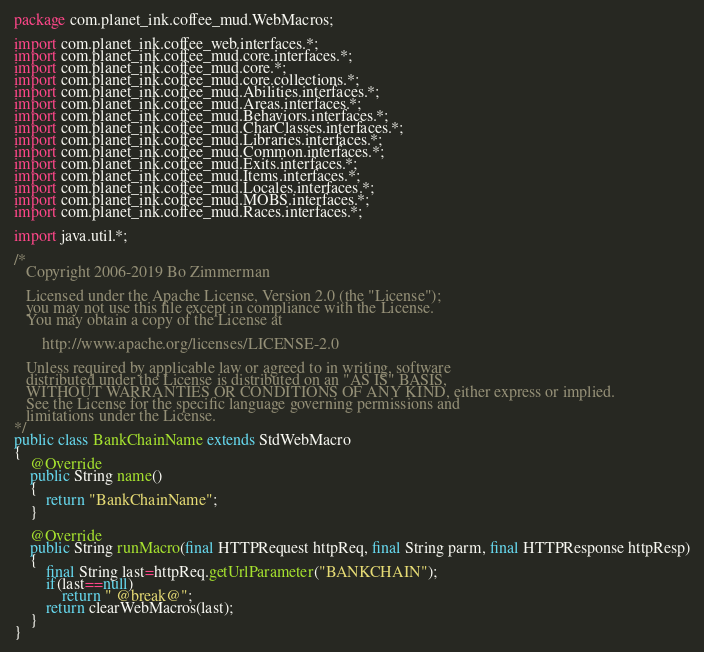Convert code to text. <code><loc_0><loc_0><loc_500><loc_500><_Java_>package com.planet_ink.coffee_mud.WebMacros;

import com.planet_ink.coffee_web.interfaces.*;
import com.planet_ink.coffee_mud.core.interfaces.*;
import com.planet_ink.coffee_mud.core.*;
import com.planet_ink.coffee_mud.core.collections.*;
import com.planet_ink.coffee_mud.Abilities.interfaces.*;
import com.planet_ink.coffee_mud.Areas.interfaces.*;
import com.planet_ink.coffee_mud.Behaviors.interfaces.*;
import com.planet_ink.coffee_mud.CharClasses.interfaces.*;
import com.planet_ink.coffee_mud.Libraries.interfaces.*;
import com.planet_ink.coffee_mud.Common.interfaces.*;
import com.planet_ink.coffee_mud.Exits.interfaces.*;
import com.planet_ink.coffee_mud.Items.interfaces.*;
import com.planet_ink.coffee_mud.Locales.interfaces.*;
import com.planet_ink.coffee_mud.MOBS.interfaces.*;
import com.planet_ink.coffee_mud.Races.interfaces.*;

import java.util.*;

/*
   Copyright 2006-2019 Bo Zimmerman

   Licensed under the Apache License, Version 2.0 (the "License");
   you may not use this file except in compliance with the License.
   You may obtain a copy of the License at

	   http://www.apache.org/licenses/LICENSE-2.0

   Unless required by applicable law or agreed to in writing, software
   distributed under the License is distributed on an "AS IS" BASIS,
   WITHOUT WARRANTIES OR CONDITIONS OF ANY KIND, either express or implied.
   See the License for the specific language governing permissions and
   limitations under the License.
*/
public class BankChainName extends StdWebMacro
{
	@Override
	public String name()
	{
		return "BankChainName";
	}

	@Override
	public String runMacro(final HTTPRequest httpReq, final String parm, final HTTPResponse httpResp)
	{
		final String last=httpReq.getUrlParameter("BANKCHAIN");
		if(last==null)
			return " @break@";
		return clearWebMacros(last);
	}
}
</code> 